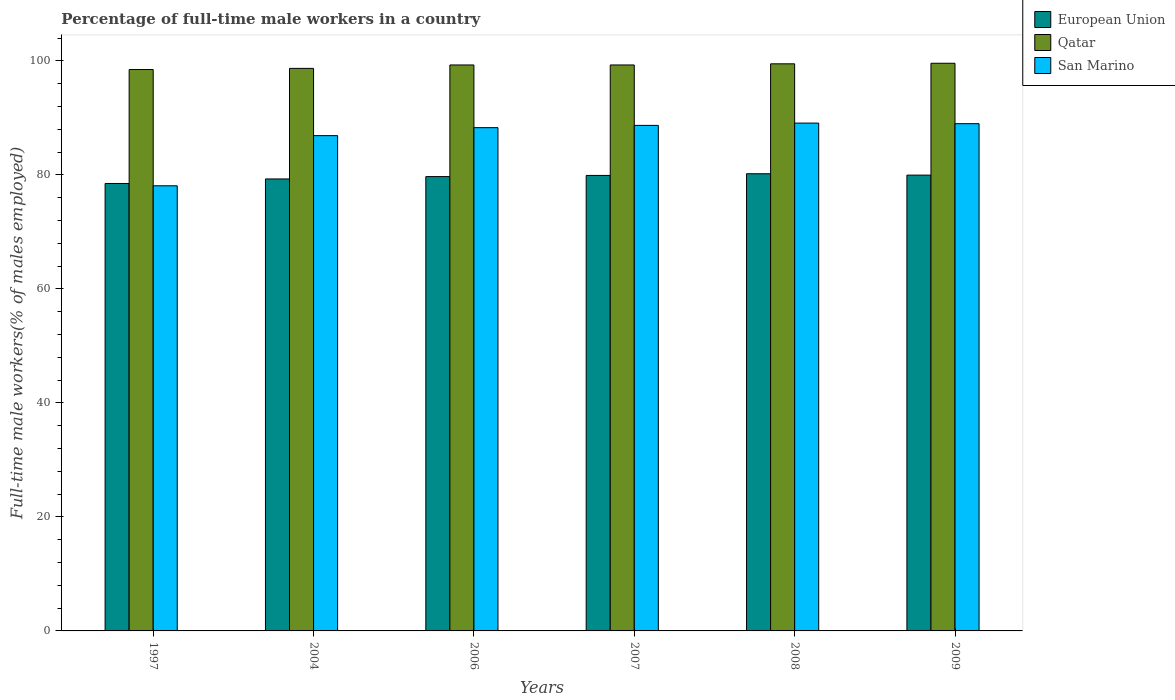How many groups of bars are there?
Offer a very short reply. 6. Are the number of bars per tick equal to the number of legend labels?
Keep it short and to the point. Yes. Are the number of bars on each tick of the X-axis equal?
Offer a very short reply. Yes. How many bars are there on the 1st tick from the right?
Ensure brevity in your answer.  3. In how many cases, is the number of bars for a given year not equal to the number of legend labels?
Your answer should be compact. 0. What is the percentage of full-time male workers in Qatar in 2007?
Your answer should be compact. 99.3. Across all years, what is the maximum percentage of full-time male workers in San Marino?
Ensure brevity in your answer.  89.1. Across all years, what is the minimum percentage of full-time male workers in Qatar?
Keep it short and to the point. 98.5. In which year was the percentage of full-time male workers in Qatar maximum?
Your response must be concise. 2009. What is the total percentage of full-time male workers in Qatar in the graph?
Your answer should be compact. 594.9. What is the difference between the percentage of full-time male workers in San Marino in 1997 and that in 2009?
Your response must be concise. -10.9. What is the difference between the percentage of full-time male workers in San Marino in 2007 and the percentage of full-time male workers in Qatar in 1997?
Give a very brief answer. -9.8. What is the average percentage of full-time male workers in Qatar per year?
Offer a terse response. 99.15. What is the ratio of the percentage of full-time male workers in Qatar in 2006 to that in 2009?
Ensure brevity in your answer.  1. Is the percentage of full-time male workers in European Union in 2006 less than that in 2007?
Ensure brevity in your answer.  Yes. What is the difference between the highest and the second highest percentage of full-time male workers in Qatar?
Offer a very short reply. 0.1. What is the difference between the highest and the lowest percentage of full-time male workers in European Union?
Give a very brief answer. 1.71. What does the 2nd bar from the left in 2008 represents?
Keep it short and to the point. Qatar. What does the 1st bar from the right in 2006 represents?
Ensure brevity in your answer.  San Marino. Is it the case that in every year, the sum of the percentage of full-time male workers in San Marino and percentage of full-time male workers in Qatar is greater than the percentage of full-time male workers in European Union?
Your answer should be very brief. Yes. How many years are there in the graph?
Provide a short and direct response. 6. Are the values on the major ticks of Y-axis written in scientific E-notation?
Offer a very short reply. No. Does the graph contain any zero values?
Your answer should be very brief. No. Does the graph contain grids?
Your answer should be very brief. No. What is the title of the graph?
Offer a very short reply. Percentage of full-time male workers in a country. What is the label or title of the X-axis?
Ensure brevity in your answer.  Years. What is the label or title of the Y-axis?
Ensure brevity in your answer.  Full-time male workers(% of males employed). What is the Full-time male workers(% of males employed) of European Union in 1997?
Ensure brevity in your answer.  78.51. What is the Full-time male workers(% of males employed) of Qatar in 1997?
Give a very brief answer. 98.5. What is the Full-time male workers(% of males employed) in San Marino in 1997?
Make the answer very short. 78.1. What is the Full-time male workers(% of males employed) of European Union in 2004?
Your answer should be compact. 79.3. What is the Full-time male workers(% of males employed) in Qatar in 2004?
Your response must be concise. 98.7. What is the Full-time male workers(% of males employed) in San Marino in 2004?
Your response must be concise. 86.9. What is the Full-time male workers(% of males employed) of European Union in 2006?
Your answer should be compact. 79.71. What is the Full-time male workers(% of males employed) in Qatar in 2006?
Provide a short and direct response. 99.3. What is the Full-time male workers(% of males employed) in San Marino in 2006?
Provide a succinct answer. 88.3. What is the Full-time male workers(% of males employed) in European Union in 2007?
Keep it short and to the point. 79.92. What is the Full-time male workers(% of males employed) of Qatar in 2007?
Keep it short and to the point. 99.3. What is the Full-time male workers(% of males employed) of San Marino in 2007?
Your answer should be very brief. 88.7. What is the Full-time male workers(% of males employed) in European Union in 2008?
Make the answer very short. 80.21. What is the Full-time male workers(% of males employed) of Qatar in 2008?
Offer a terse response. 99.5. What is the Full-time male workers(% of males employed) in San Marino in 2008?
Offer a very short reply. 89.1. What is the Full-time male workers(% of males employed) of European Union in 2009?
Your answer should be compact. 79.97. What is the Full-time male workers(% of males employed) of Qatar in 2009?
Offer a terse response. 99.6. What is the Full-time male workers(% of males employed) of San Marino in 2009?
Keep it short and to the point. 89. Across all years, what is the maximum Full-time male workers(% of males employed) of European Union?
Provide a short and direct response. 80.21. Across all years, what is the maximum Full-time male workers(% of males employed) in Qatar?
Give a very brief answer. 99.6. Across all years, what is the maximum Full-time male workers(% of males employed) in San Marino?
Make the answer very short. 89.1. Across all years, what is the minimum Full-time male workers(% of males employed) in European Union?
Keep it short and to the point. 78.51. Across all years, what is the minimum Full-time male workers(% of males employed) in Qatar?
Provide a short and direct response. 98.5. Across all years, what is the minimum Full-time male workers(% of males employed) in San Marino?
Offer a terse response. 78.1. What is the total Full-time male workers(% of males employed) of European Union in the graph?
Provide a short and direct response. 477.63. What is the total Full-time male workers(% of males employed) in Qatar in the graph?
Your answer should be compact. 594.9. What is the total Full-time male workers(% of males employed) of San Marino in the graph?
Offer a terse response. 520.1. What is the difference between the Full-time male workers(% of males employed) in European Union in 1997 and that in 2004?
Provide a succinct answer. -0.8. What is the difference between the Full-time male workers(% of males employed) in Qatar in 1997 and that in 2004?
Offer a very short reply. -0.2. What is the difference between the Full-time male workers(% of males employed) of San Marino in 1997 and that in 2004?
Provide a succinct answer. -8.8. What is the difference between the Full-time male workers(% of males employed) of European Union in 1997 and that in 2006?
Make the answer very short. -1.21. What is the difference between the Full-time male workers(% of males employed) in Qatar in 1997 and that in 2006?
Offer a very short reply. -0.8. What is the difference between the Full-time male workers(% of males employed) in San Marino in 1997 and that in 2006?
Provide a succinct answer. -10.2. What is the difference between the Full-time male workers(% of males employed) in European Union in 1997 and that in 2007?
Your answer should be compact. -1.41. What is the difference between the Full-time male workers(% of males employed) in San Marino in 1997 and that in 2007?
Offer a terse response. -10.6. What is the difference between the Full-time male workers(% of males employed) in European Union in 1997 and that in 2008?
Make the answer very short. -1.71. What is the difference between the Full-time male workers(% of males employed) of San Marino in 1997 and that in 2008?
Keep it short and to the point. -11. What is the difference between the Full-time male workers(% of males employed) of European Union in 1997 and that in 2009?
Offer a terse response. -1.47. What is the difference between the Full-time male workers(% of males employed) in European Union in 2004 and that in 2006?
Provide a succinct answer. -0.41. What is the difference between the Full-time male workers(% of males employed) in Qatar in 2004 and that in 2006?
Offer a terse response. -0.6. What is the difference between the Full-time male workers(% of males employed) of San Marino in 2004 and that in 2006?
Provide a short and direct response. -1.4. What is the difference between the Full-time male workers(% of males employed) of European Union in 2004 and that in 2007?
Offer a very short reply. -0.62. What is the difference between the Full-time male workers(% of males employed) in Qatar in 2004 and that in 2007?
Provide a short and direct response. -0.6. What is the difference between the Full-time male workers(% of males employed) of European Union in 2004 and that in 2008?
Make the answer very short. -0.91. What is the difference between the Full-time male workers(% of males employed) in San Marino in 2004 and that in 2008?
Make the answer very short. -2.2. What is the difference between the Full-time male workers(% of males employed) in European Union in 2004 and that in 2009?
Offer a terse response. -0.67. What is the difference between the Full-time male workers(% of males employed) of San Marino in 2004 and that in 2009?
Make the answer very short. -2.1. What is the difference between the Full-time male workers(% of males employed) of European Union in 2006 and that in 2007?
Your response must be concise. -0.21. What is the difference between the Full-time male workers(% of males employed) in Qatar in 2006 and that in 2007?
Your answer should be compact. 0. What is the difference between the Full-time male workers(% of males employed) in San Marino in 2006 and that in 2007?
Offer a very short reply. -0.4. What is the difference between the Full-time male workers(% of males employed) of European Union in 2006 and that in 2008?
Make the answer very short. -0.5. What is the difference between the Full-time male workers(% of males employed) in Qatar in 2006 and that in 2008?
Make the answer very short. -0.2. What is the difference between the Full-time male workers(% of males employed) in European Union in 2006 and that in 2009?
Offer a very short reply. -0.26. What is the difference between the Full-time male workers(% of males employed) of European Union in 2007 and that in 2008?
Your answer should be very brief. -0.3. What is the difference between the Full-time male workers(% of males employed) in European Union in 2007 and that in 2009?
Make the answer very short. -0.05. What is the difference between the Full-time male workers(% of males employed) of Qatar in 2007 and that in 2009?
Your answer should be very brief. -0.3. What is the difference between the Full-time male workers(% of males employed) of European Union in 2008 and that in 2009?
Your response must be concise. 0.24. What is the difference between the Full-time male workers(% of males employed) in European Union in 1997 and the Full-time male workers(% of males employed) in Qatar in 2004?
Make the answer very short. -20.19. What is the difference between the Full-time male workers(% of males employed) of European Union in 1997 and the Full-time male workers(% of males employed) of San Marino in 2004?
Give a very brief answer. -8.39. What is the difference between the Full-time male workers(% of males employed) in Qatar in 1997 and the Full-time male workers(% of males employed) in San Marino in 2004?
Provide a short and direct response. 11.6. What is the difference between the Full-time male workers(% of males employed) of European Union in 1997 and the Full-time male workers(% of males employed) of Qatar in 2006?
Keep it short and to the point. -20.79. What is the difference between the Full-time male workers(% of males employed) of European Union in 1997 and the Full-time male workers(% of males employed) of San Marino in 2006?
Provide a succinct answer. -9.79. What is the difference between the Full-time male workers(% of males employed) in Qatar in 1997 and the Full-time male workers(% of males employed) in San Marino in 2006?
Provide a succinct answer. 10.2. What is the difference between the Full-time male workers(% of males employed) in European Union in 1997 and the Full-time male workers(% of males employed) in Qatar in 2007?
Your answer should be very brief. -20.79. What is the difference between the Full-time male workers(% of males employed) in European Union in 1997 and the Full-time male workers(% of males employed) in San Marino in 2007?
Make the answer very short. -10.19. What is the difference between the Full-time male workers(% of males employed) in Qatar in 1997 and the Full-time male workers(% of males employed) in San Marino in 2007?
Offer a very short reply. 9.8. What is the difference between the Full-time male workers(% of males employed) in European Union in 1997 and the Full-time male workers(% of males employed) in Qatar in 2008?
Provide a short and direct response. -20.99. What is the difference between the Full-time male workers(% of males employed) in European Union in 1997 and the Full-time male workers(% of males employed) in San Marino in 2008?
Offer a terse response. -10.59. What is the difference between the Full-time male workers(% of males employed) in Qatar in 1997 and the Full-time male workers(% of males employed) in San Marino in 2008?
Provide a succinct answer. 9.4. What is the difference between the Full-time male workers(% of males employed) of European Union in 1997 and the Full-time male workers(% of males employed) of Qatar in 2009?
Provide a short and direct response. -21.09. What is the difference between the Full-time male workers(% of males employed) of European Union in 1997 and the Full-time male workers(% of males employed) of San Marino in 2009?
Give a very brief answer. -10.49. What is the difference between the Full-time male workers(% of males employed) of Qatar in 1997 and the Full-time male workers(% of males employed) of San Marino in 2009?
Offer a terse response. 9.5. What is the difference between the Full-time male workers(% of males employed) of European Union in 2004 and the Full-time male workers(% of males employed) of Qatar in 2006?
Make the answer very short. -20. What is the difference between the Full-time male workers(% of males employed) in European Union in 2004 and the Full-time male workers(% of males employed) in San Marino in 2006?
Provide a succinct answer. -9. What is the difference between the Full-time male workers(% of males employed) in European Union in 2004 and the Full-time male workers(% of males employed) in Qatar in 2007?
Your answer should be very brief. -20. What is the difference between the Full-time male workers(% of males employed) in European Union in 2004 and the Full-time male workers(% of males employed) in San Marino in 2007?
Give a very brief answer. -9.4. What is the difference between the Full-time male workers(% of males employed) of European Union in 2004 and the Full-time male workers(% of males employed) of Qatar in 2008?
Provide a short and direct response. -20.2. What is the difference between the Full-time male workers(% of males employed) in European Union in 2004 and the Full-time male workers(% of males employed) in San Marino in 2008?
Make the answer very short. -9.8. What is the difference between the Full-time male workers(% of males employed) in Qatar in 2004 and the Full-time male workers(% of males employed) in San Marino in 2008?
Offer a terse response. 9.6. What is the difference between the Full-time male workers(% of males employed) in European Union in 2004 and the Full-time male workers(% of males employed) in Qatar in 2009?
Make the answer very short. -20.3. What is the difference between the Full-time male workers(% of males employed) of European Union in 2004 and the Full-time male workers(% of males employed) of San Marino in 2009?
Make the answer very short. -9.7. What is the difference between the Full-time male workers(% of males employed) of European Union in 2006 and the Full-time male workers(% of males employed) of Qatar in 2007?
Keep it short and to the point. -19.59. What is the difference between the Full-time male workers(% of males employed) of European Union in 2006 and the Full-time male workers(% of males employed) of San Marino in 2007?
Ensure brevity in your answer.  -8.99. What is the difference between the Full-time male workers(% of males employed) in Qatar in 2006 and the Full-time male workers(% of males employed) in San Marino in 2007?
Keep it short and to the point. 10.6. What is the difference between the Full-time male workers(% of males employed) of European Union in 2006 and the Full-time male workers(% of males employed) of Qatar in 2008?
Keep it short and to the point. -19.79. What is the difference between the Full-time male workers(% of males employed) of European Union in 2006 and the Full-time male workers(% of males employed) of San Marino in 2008?
Provide a short and direct response. -9.39. What is the difference between the Full-time male workers(% of males employed) in European Union in 2006 and the Full-time male workers(% of males employed) in Qatar in 2009?
Ensure brevity in your answer.  -19.89. What is the difference between the Full-time male workers(% of males employed) in European Union in 2006 and the Full-time male workers(% of males employed) in San Marino in 2009?
Your answer should be compact. -9.29. What is the difference between the Full-time male workers(% of males employed) of European Union in 2007 and the Full-time male workers(% of males employed) of Qatar in 2008?
Give a very brief answer. -19.58. What is the difference between the Full-time male workers(% of males employed) in European Union in 2007 and the Full-time male workers(% of males employed) in San Marino in 2008?
Offer a terse response. -9.18. What is the difference between the Full-time male workers(% of males employed) of European Union in 2007 and the Full-time male workers(% of males employed) of Qatar in 2009?
Provide a short and direct response. -19.68. What is the difference between the Full-time male workers(% of males employed) in European Union in 2007 and the Full-time male workers(% of males employed) in San Marino in 2009?
Provide a succinct answer. -9.08. What is the difference between the Full-time male workers(% of males employed) of Qatar in 2007 and the Full-time male workers(% of males employed) of San Marino in 2009?
Your response must be concise. 10.3. What is the difference between the Full-time male workers(% of males employed) in European Union in 2008 and the Full-time male workers(% of males employed) in Qatar in 2009?
Offer a terse response. -19.39. What is the difference between the Full-time male workers(% of males employed) of European Union in 2008 and the Full-time male workers(% of males employed) of San Marino in 2009?
Provide a short and direct response. -8.79. What is the average Full-time male workers(% of males employed) of European Union per year?
Offer a very short reply. 79.6. What is the average Full-time male workers(% of males employed) in Qatar per year?
Provide a short and direct response. 99.15. What is the average Full-time male workers(% of males employed) of San Marino per year?
Offer a very short reply. 86.68. In the year 1997, what is the difference between the Full-time male workers(% of males employed) of European Union and Full-time male workers(% of males employed) of Qatar?
Provide a succinct answer. -19.99. In the year 1997, what is the difference between the Full-time male workers(% of males employed) of European Union and Full-time male workers(% of males employed) of San Marino?
Provide a short and direct response. 0.41. In the year 1997, what is the difference between the Full-time male workers(% of males employed) of Qatar and Full-time male workers(% of males employed) of San Marino?
Ensure brevity in your answer.  20.4. In the year 2004, what is the difference between the Full-time male workers(% of males employed) of European Union and Full-time male workers(% of males employed) of Qatar?
Ensure brevity in your answer.  -19.4. In the year 2004, what is the difference between the Full-time male workers(% of males employed) of European Union and Full-time male workers(% of males employed) of San Marino?
Offer a very short reply. -7.6. In the year 2004, what is the difference between the Full-time male workers(% of males employed) in Qatar and Full-time male workers(% of males employed) in San Marino?
Offer a terse response. 11.8. In the year 2006, what is the difference between the Full-time male workers(% of males employed) of European Union and Full-time male workers(% of males employed) of Qatar?
Provide a succinct answer. -19.59. In the year 2006, what is the difference between the Full-time male workers(% of males employed) of European Union and Full-time male workers(% of males employed) of San Marino?
Provide a short and direct response. -8.59. In the year 2006, what is the difference between the Full-time male workers(% of males employed) in Qatar and Full-time male workers(% of males employed) in San Marino?
Provide a succinct answer. 11. In the year 2007, what is the difference between the Full-time male workers(% of males employed) in European Union and Full-time male workers(% of males employed) in Qatar?
Provide a short and direct response. -19.38. In the year 2007, what is the difference between the Full-time male workers(% of males employed) in European Union and Full-time male workers(% of males employed) in San Marino?
Give a very brief answer. -8.78. In the year 2008, what is the difference between the Full-time male workers(% of males employed) in European Union and Full-time male workers(% of males employed) in Qatar?
Ensure brevity in your answer.  -19.29. In the year 2008, what is the difference between the Full-time male workers(% of males employed) in European Union and Full-time male workers(% of males employed) in San Marino?
Offer a terse response. -8.89. In the year 2008, what is the difference between the Full-time male workers(% of males employed) of Qatar and Full-time male workers(% of males employed) of San Marino?
Keep it short and to the point. 10.4. In the year 2009, what is the difference between the Full-time male workers(% of males employed) of European Union and Full-time male workers(% of males employed) of Qatar?
Offer a very short reply. -19.63. In the year 2009, what is the difference between the Full-time male workers(% of males employed) of European Union and Full-time male workers(% of males employed) of San Marino?
Your answer should be compact. -9.03. In the year 2009, what is the difference between the Full-time male workers(% of males employed) in Qatar and Full-time male workers(% of males employed) in San Marino?
Your response must be concise. 10.6. What is the ratio of the Full-time male workers(% of males employed) in San Marino in 1997 to that in 2004?
Make the answer very short. 0.9. What is the ratio of the Full-time male workers(% of males employed) of European Union in 1997 to that in 2006?
Ensure brevity in your answer.  0.98. What is the ratio of the Full-time male workers(% of males employed) of San Marino in 1997 to that in 2006?
Your response must be concise. 0.88. What is the ratio of the Full-time male workers(% of males employed) of European Union in 1997 to that in 2007?
Give a very brief answer. 0.98. What is the ratio of the Full-time male workers(% of males employed) in San Marino in 1997 to that in 2007?
Offer a terse response. 0.88. What is the ratio of the Full-time male workers(% of males employed) in European Union in 1997 to that in 2008?
Make the answer very short. 0.98. What is the ratio of the Full-time male workers(% of males employed) of Qatar in 1997 to that in 2008?
Offer a very short reply. 0.99. What is the ratio of the Full-time male workers(% of males employed) of San Marino in 1997 to that in 2008?
Offer a very short reply. 0.88. What is the ratio of the Full-time male workers(% of males employed) of European Union in 1997 to that in 2009?
Ensure brevity in your answer.  0.98. What is the ratio of the Full-time male workers(% of males employed) in San Marino in 1997 to that in 2009?
Keep it short and to the point. 0.88. What is the ratio of the Full-time male workers(% of males employed) of Qatar in 2004 to that in 2006?
Your answer should be very brief. 0.99. What is the ratio of the Full-time male workers(% of males employed) in San Marino in 2004 to that in 2006?
Provide a succinct answer. 0.98. What is the ratio of the Full-time male workers(% of males employed) in European Union in 2004 to that in 2007?
Your answer should be very brief. 0.99. What is the ratio of the Full-time male workers(% of males employed) of Qatar in 2004 to that in 2007?
Offer a terse response. 0.99. What is the ratio of the Full-time male workers(% of males employed) of San Marino in 2004 to that in 2007?
Ensure brevity in your answer.  0.98. What is the ratio of the Full-time male workers(% of males employed) in San Marino in 2004 to that in 2008?
Your answer should be compact. 0.98. What is the ratio of the Full-time male workers(% of males employed) of European Union in 2004 to that in 2009?
Your answer should be compact. 0.99. What is the ratio of the Full-time male workers(% of males employed) of Qatar in 2004 to that in 2009?
Offer a terse response. 0.99. What is the ratio of the Full-time male workers(% of males employed) in San Marino in 2004 to that in 2009?
Your response must be concise. 0.98. What is the ratio of the Full-time male workers(% of males employed) of European Union in 2006 to that in 2007?
Keep it short and to the point. 1. What is the ratio of the Full-time male workers(% of males employed) in Qatar in 2006 to that in 2008?
Offer a terse response. 1. What is the ratio of the Full-time male workers(% of males employed) of Qatar in 2006 to that in 2009?
Offer a terse response. 1. What is the ratio of the Full-time male workers(% of males employed) in Qatar in 2007 to that in 2008?
Ensure brevity in your answer.  1. What is the ratio of the Full-time male workers(% of males employed) in San Marino in 2007 to that in 2008?
Offer a terse response. 1. What is the ratio of the Full-time male workers(% of males employed) in San Marino in 2007 to that in 2009?
Give a very brief answer. 1. What is the ratio of the Full-time male workers(% of males employed) of European Union in 2008 to that in 2009?
Provide a succinct answer. 1. What is the ratio of the Full-time male workers(% of males employed) in Qatar in 2008 to that in 2009?
Provide a succinct answer. 1. What is the difference between the highest and the second highest Full-time male workers(% of males employed) in European Union?
Provide a short and direct response. 0.24. What is the difference between the highest and the second highest Full-time male workers(% of males employed) in Qatar?
Offer a terse response. 0.1. What is the difference between the highest and the lowest Full-time male workers(% of males employed) in European Union?
Make the answer very short. 1.71. What is the difference between the highest and the lowest Full-time male workers(% of males employed) in Qatar?
Your response must be concise. 1.1. 